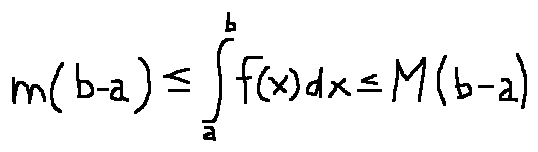<formula> <loc_0><loc_0><loc_500><loc_500>m ( b - a ) \leq \int \lim i t s _ { a } ^ { b } f ( x ) d x \leq M ( b - a )</formula> 